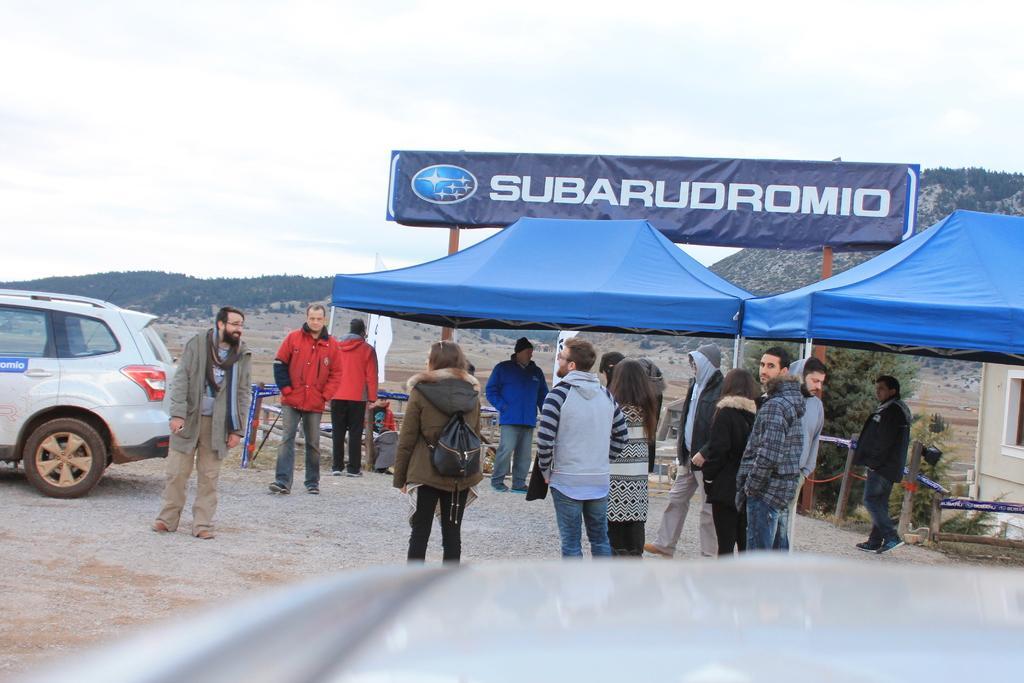Please provide a concise description of this image. There are many people. On the right side there are tents. On the left side there is a vehicle. Also there is a banner near the tents. In the background there is a hill and sky. 